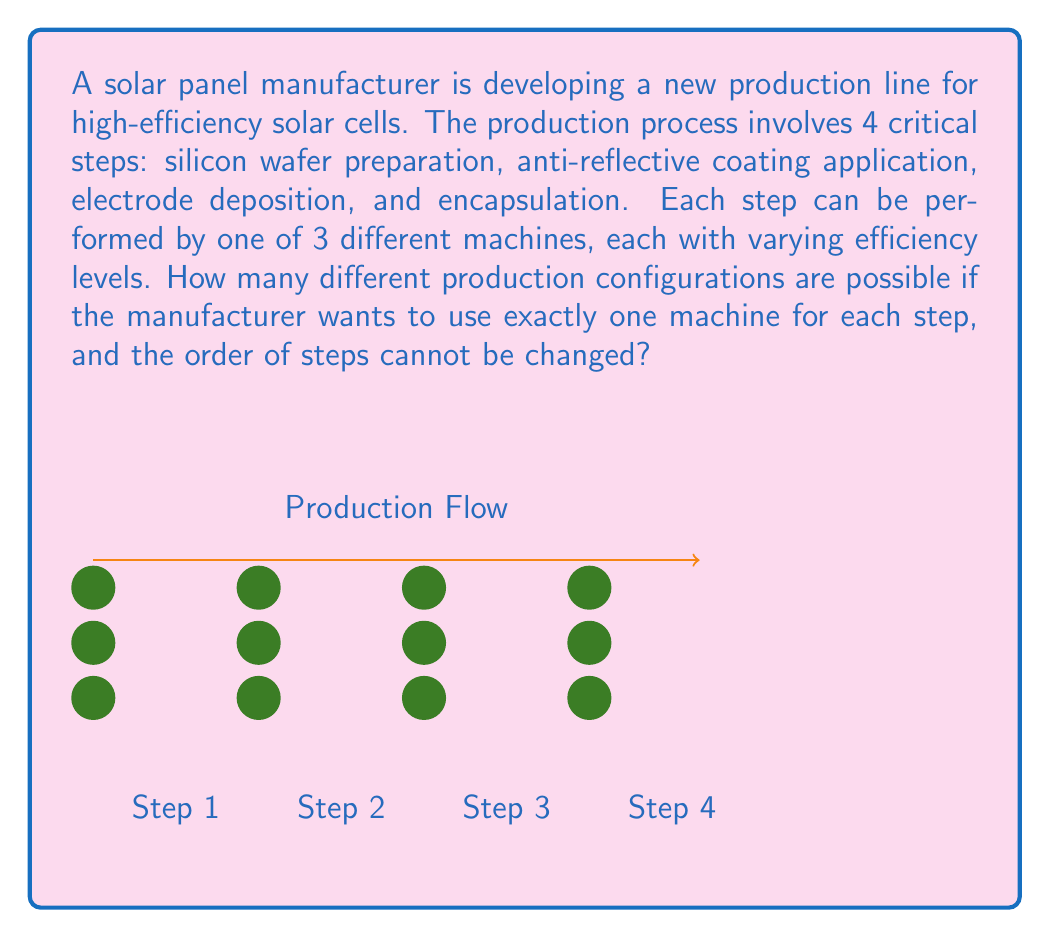Could you help me with this problem? To solve this problem, we can use the multiplication principle of combinatorics. Here's a step-by-step explanation:

1) We have 4 steps in the production process, and for each step, we need to choose 1 machine out of 3 possible machines.

2) The choices for each step are independent of the choices for other steps, meaning the selection of a machine for one step doesn't affect the available choices for other steps.

3) For the first step, we have 3 choices.
   For the second step, we again have 3 choices.
   This pattern continues for the third and fourth steps.

4) According to the multiplication principle, when we have a sequence of independent choices, the total number of possible outcomes is the product of the number of choices for each decision.

5) Therefore, the total number of possible configurations is:

   $$ 3 \times 3 \times 3 \times 3 = 3^4 = 81 $$

This calculation can be interpreted as follows:
- We have 4 choices to make (one for each step)
- For each choice, we have 3 options (3 machines)
- The exponent 4 in $3^4$ represents the number of steps

Thus, there are 81 different ways to configure the production line using exactly one machine for each of the four steps.
Answer: 81 